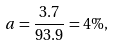<formula> <loc_0><loc_0><loc_500><loc_500>a = \frac { 3 . 7 } { 9 3 . 9 } = 4 \% ,</formula> 